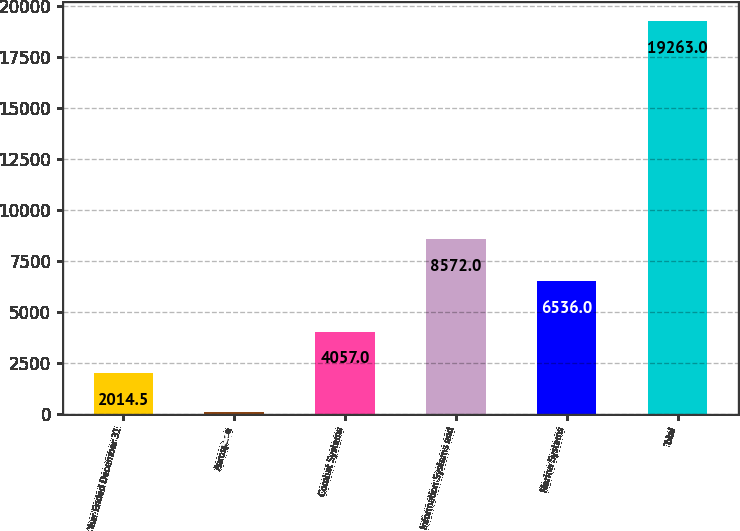Convert chart to OTSL. <chart><loc_0><loc_0><loc_500><loc_500><bar_chart><fcel>Year Ended December 31<fcel>Aerospace<fcel>Combat Systems<fcel>Information Systems and<fcel>Marine Systems<fcel>Total<nl><fcel>2014.5<fcel>98<fcel>4057<fcel>8572<fcel>6536<fcel>19263<nl></chart> 